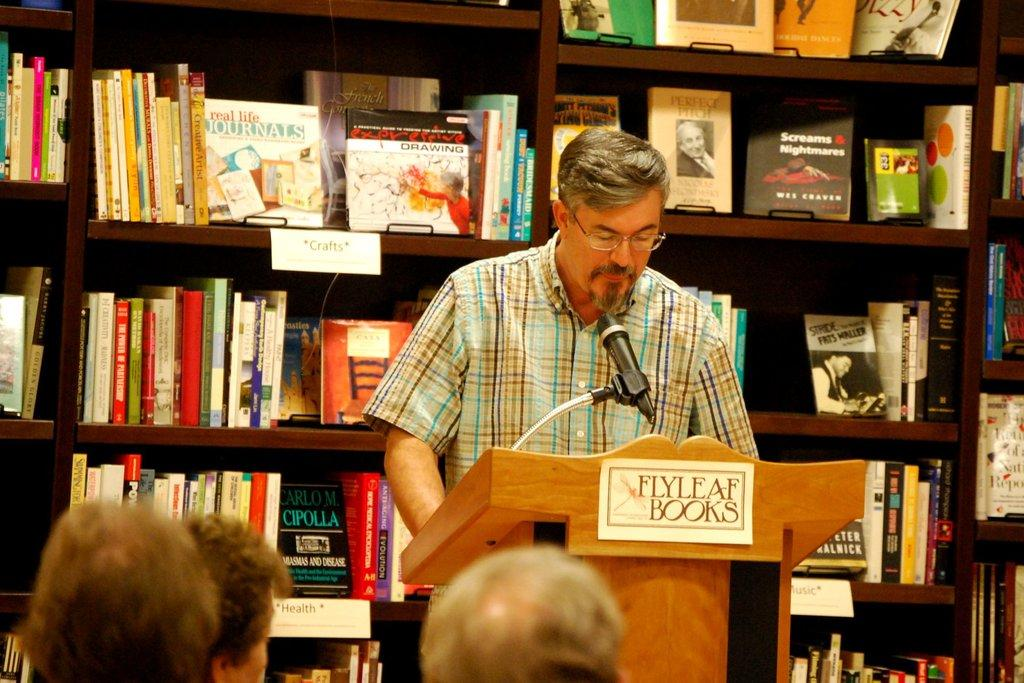Provide a one-sentence caption for the provided image. A man stands at a podium in the Flyleaf Books bookstore speaking to a group of people. 